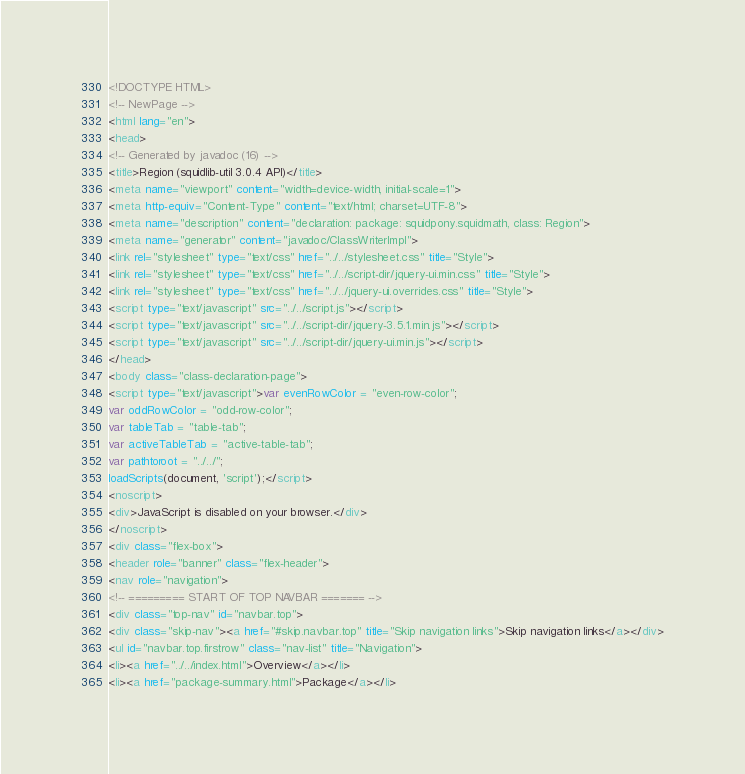<code> <loc_0><loc_0><loc_500><loc_500><_HTML_><!DOCTYPE HTML>
<!-- NewPage -->
<html lang="en">
<head>
<!-- Generated by javadoc (16) -->
<title>Region (squidlib-util 3.0.4 API)</title>
<meta name="viewport" content="width=device-width, initial-scale=1">
<meta http-equiv="Content-Type" content="text/html; charset=UTF-8">
<meta name="description" content="declaration: package: squidpony.squidmath, class: Region">
<meta name="generator" content="javadoc/ClassWriterImpl">
<link rel="stylesheet" type="text/css" href="../../stylesheet.css" title="Style">
<link rel="stylesheet" type="text/css" href="../../script-dir/jquery-ui.min.css" title="Style">
<link rel="stylesheet" type="text/css" href="../../jquery-ui.overrides.css" title="Style">
<script type="text/javascript" src="../../script.js"></script>
<script type="text/javascript" src="../../script-dir/jquery-3.5.1.min.js"></script>
<script type="text/javascript" src="../../script-dir/jquery-ui.min.js"></script>
</head>
<body class="class-declaration-page">
<script type="text/javascript">var evenRowColor = "even-row-color";
var oddRowColor = "odd-row-color";
var tableTab = "table-tab";
var activeTableTab = "active-table-tab";
var pathtoroot = "../../";
loadScripts(document, 'script');</script>
<noscript>
<div>JavaScript is disabled on your browser.</div>
</noscript>
<div class="flex-box">
<header role="banner" class="flex-header">
<nav role="navigation">
<!-- ========= START OF TOP NAVBAR ======= -->
<div class="top-nav" id="navbar.top">
<div class="skip-nav"><a href="#skip.navbar.top" title="Skip navigation links">Skip navigation links</a></div>
<ul id="navbar.top.firstrow" class="nav-list" title="Navigation">
<li><a href="../../index.html">Overview</a></li>
<li><a href="package-summary.html">Package</a></li></code> 